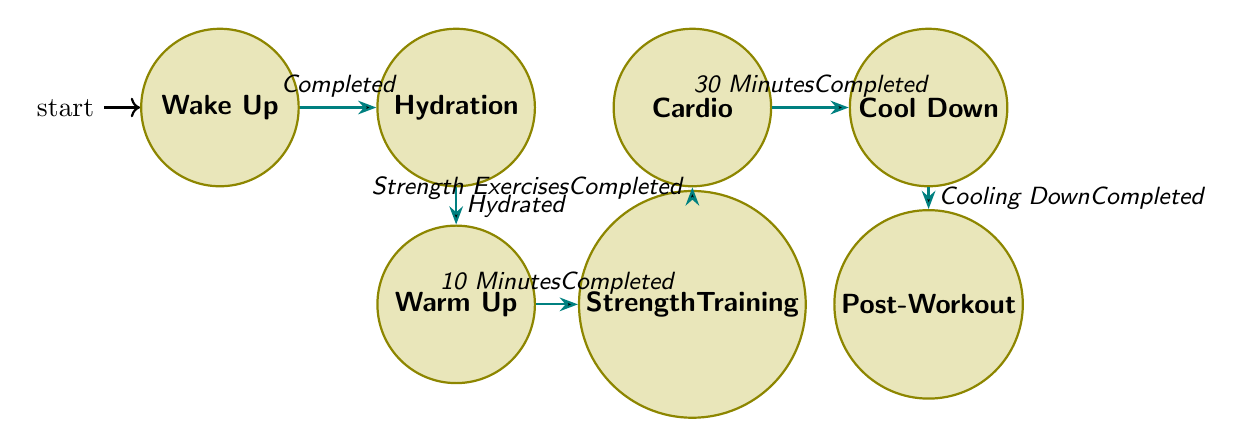What is the first state in the regimen? The diagram starts with the initial state labeled "Wake Up", which is where the fitness routine begins.
Answer: Wake Up How many states are present in the fitness regimen diagram? By counting the individual states labeled in the diagram, we find a total of seven distinct states: Wake Up, Hydration, Warm Up, Strength Training, Cardio, Cool Down, and Post-Workout.
Answer: 7 What actions are associated with the "Strength Training" state? The diagram lists three actions that occur within the "Strength Training" state: Push-ups, Sit-ups, and Planks.
Answer: Push-ups, Sit-ups, Planks Which state follows "Warm Up"? According to the transition arrows shown in the diagram, the state that immediately follows "Warm Up" is "Strength Training".
Answer: Strength Training What is the trigger that moves from "Hydration" to "Warm Up"? The transition arrow indicates that the trigger for moving from "Hydration" to "Warm Up" is labeled "Hydrated", which must be completed to progress.
Answer: Hydrated What state occurs after completing the "Cool Down"? Upon completion of the "Cool Down" state, the diagram shows the next state is "Post-Workout", indicating the final step of the routine.
Answer: Post-Workout How many actions are listed in the "Cardio" state? In the "Cardio" state, there is one action indicated, which is "30-Minute Cycling Session". Thus, the count of actions provides the answer.
Answer: 1 What are the actions performed when transitioning from "Cardio" to "Cool Down"? There are no specific actions indicated for the transition between "Cardio" and "Cool Down"; rather, this transition is solely based on the completion of the "30 Minutes" in the Cardio state.
Answer: None Identify the relationship between "Wake Up" and "Hydration". The relationship is that "Wake Up" is the initial state, which transitions to "Hydration" once the action "Completed" is performed, indicating a direct progression in the routine.
Answer: Completed 